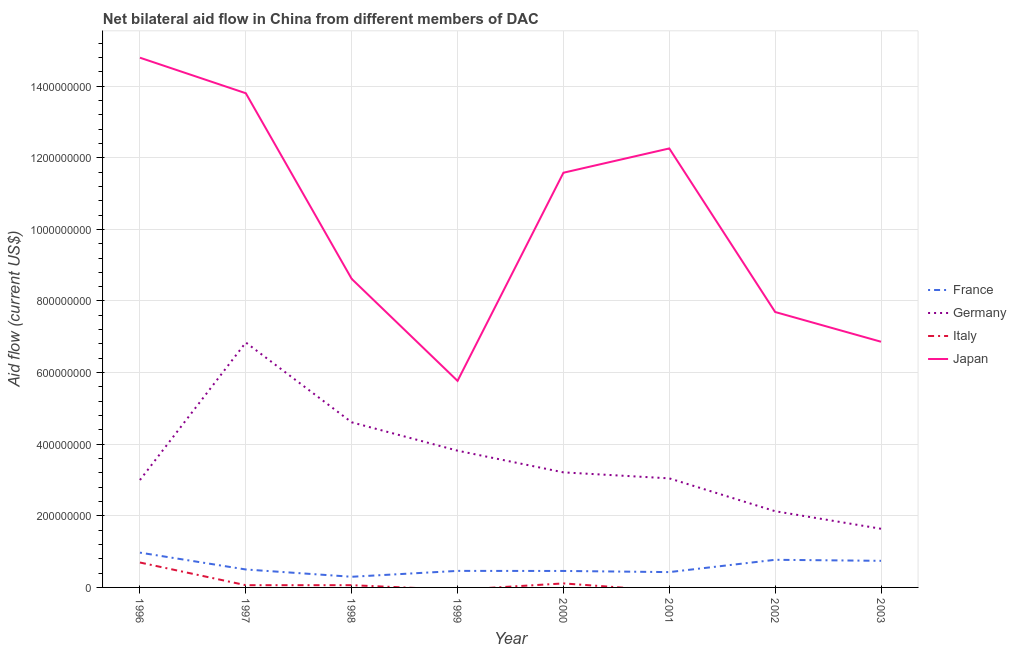How many different coloured lines are there?
Ensure brevity in your answer.  4. What is the amount of aid given by italy in 1998?
Your answer should be very brief. 6.24e+06. Across all years, what is the maximum amount of aid given by japan?
Offer a very short reply. 1.48e+09. Across all years, what is the minimum amount of aid given by germany?
Your answer should be compact. 1.64e+08. In which year was the amount of aid given by italy maximum?
Make the answer very short. 1996. What is the total amount of aid given by france in the graph?
Your answer should be compact. 4.64e+08. What is the difference between the amount of aid given by germany in 2001 and that in 2002?
Provide a succinct answer. 9.18e+07. What is the difference between the amount of aid given by germany in 1997 and the amount of aid given by japan in 2003?
Offer a very short reply. -2.08e+06. What is the average amount of aid given by japan per year?
Provide a short and direct response. 1.02e+09. In the year 2000, what is the difference between the amount of aid given by germany and amount of aid given by france?
Give a very brief answer. 2.75e+08. What is the ratio of the amount of aid given by germany in 1996 to that in 1997?
Your response must be concise. 0.44. Is the amount of aid given by japan in 1999 less than that in 2003?
Make the answer very short. Yes. Is the difference between the amount of aid given by germany in 1999 and 2000 greater than the difference between the amount of aid given by japan in 1999 and 2000?
Offer a very short reply. Yes. What is the difference between the highest and the second highest amount of aid given by japan?
Provide a succinct answer. 9.93e+07. What is the difference between the highest and the lowest amount of aid given by japan?
Your response must be concise. 9.03e+08. In how many years, is the amount of aid given by france greater than the average amount of aid given by france taken over all years?
Give a very brief answer. 3. Is it the case that in every year, the sum of the amount of aid given by japan and amount of aid given by germany is greater than the sum of amount of aid given by france and amount of aid given by italy?
Your answer should be compact. No. Is the amount of aid given by italy strictly less than the amount of aid given by germany over the years?
Your answer should be very brief. Yes. How many lines are there?
Your response must be concise. 4. How many years are there in the graph?
Provide a succinct answer. 8. What is the difference between two consecutive major ticks on the Y-axis?
Your answer should be very brief. 2.00e+08. Are the values on the major ticks of Y-axis written in scientific E-notation?
Offer a terse response. No. Does the graph contain grids?
Provide a succinct answer. Yes. Where does the legend appear in the graph?
Your answer should be compact. Center right. How many legend labels are there?
Provide a short and direct response. 4. How are the legend labels stacked?
Keep it short and to the point. Vertical. What is the title of the graph?
Your answer should be compact. Net bilateral aid flow in China from different members of DAC. Does "Methodology assessment" appear as one of the legend labels in the graph?
Provide a succinct answer. No. What is the label or title of the Y-axis?
Provide a succinct answer. Aid flow (current US$). What is the Aid flow (current US$) of France in 1996?
Your answer should be very brief. 9.72e+07. What is the Aid flow (current US$) of Germany in 1996?
Offer a terse response. 3.00e+08. What is the Aid flow (current US$) of Italy in 1996?
Offer a terse response. 6.96e+07. What is the Aid flow (current US$) of Japan in 1996?
Make the answer very short. 1.48e+09. What is the Aid flow (current US$) of France in 1997?
Provide a short and direct response. 5.01e+07. What is the Aid flow (current US$) of Germany in 1997?
Keep it short and to the point. 6.84e+08. What is the Aid flow (current US$) in Italy in 1997?
Your answer should be compact. 6.23e+06. What is the Aid flow (current US$) of Japan in 1997?
Make the answer very short. 1.38e+09. What is the Aid flow (current US$) of France in 1998?
Offer a terse response. 2.98e+07. What is the Aid flow (current US$) of Germany in 1998?
Keep it short and to the point. 4.61e+08. What is the Aid flow (current US$) of Italy in 1998?
Offer a terse response. 6.24e+06. What is the Aid flow (current US$) in Japan in 1998?
Give a very brief answer. 8.62e+08. What is the Aid flow (current US$) in France in 1999?
Ensure brevity in your answer.  4.62e+07. What is the Aid flow (current US$) in Germany in 1999?
Your response must be concise. 3.82e+08. What is the Aid flow (current US$) in Italy in 1999?
Make the answer very short. 0. What is the Aid flow (current US$) of Japan in 1999?
Give a very brief answer. 5.77e+08. What is the Aid flow (current US$) of France in 2000?
Your answer should be compact. 4.60e+07. What is the Aid flow (current US$) in Germany in 2000?
Your answer should be very brief. 3.21e+08. What is the Aid flow (current US$) of Italy in 2000?
Offer a very short reply. 1.12e+07. What is the Aid flow (current US$) in Japan in 2000?
Your answer should be very brief. 1.16e+09. What is the Aid flow (current US$) in France in 2001?
Offer a very short reply. 4.28e+07. What is the Aid flow (current US$) of Germany in 2001?
Your answer should be very brief. 3.05e+08. What is the Aid flow (current US$) in Italy in 2001?
Provide a succinct answer. 0. What is the Aid flow (current US$) in Japan in 2001?
Ensure brevity in your answer.  1.23e+09. What is the Aid flow (current US$) of France in 2002?
Make the answer very short. 7.72e+07. What is the Aid flow (current US$) in Germany in 2002?
Provide a succinct answer. 2.13e+08. What is the Aid flow (current US$) of Japan in 2002?
Offer a terse response. 7.69e+08. What is the Aid flow (current US$) in France in 2003?
Your response must be concise. 7.43e+07. What is the Aid flow (current US$) in Germany in 2003?
Provide a short and direct response. 1.64e+08. What is the Aid flow (current US$) in Italy in 2003?
Make the answer very short. 0. What is the Aid flow (current US$) in Japan in 2003?
Ensure brevity in your answer.  6.86e+08. Across all years, what is the maximum Aid flow (current US$) in France?
Your response must be concise. 9.72e+07. Across all years, what is the maximum Aid flow (current US$) in Germany?
Provide a succinct answer. 6.84e+08. Across all years, what is the maximum Aid flow (current US$) in Italy?
Make the answer very short. 6.96e+07. Across all years, what is the maximum Aid flow (current US$) of Japan?
Give a very brief answer. 1.48e+09. Across all years, what is the minimum Aid flow (current US$) in France?
Make the answer very short. 2.98e+07. Across all years, what is the minimum Aid flow (current US$) of Germany?
Offer a terse response. 1.64e+08. Across all years, what is the minimum Aid flow (current US$) in Japan?
Make the answer very short. 5.77e+08. What is the total Aid flow (current US$) of France in the graph?
Keep it short and to the point. 4.64e+08. What is the total Aid flow (current US$) of Germany in the graph?
Provide a succinct answer. 2.83e+09. What is the total Aid flow (current US$) of Italy in the graph?
Provide a succinct answer. 9.33e+07. What is the total Aid flow (current US$) in Japan in the graph?
Provide a short and direct response. 8.14e+09. What is the difference between the Aid flow (current US$) of France in 1996 and that in 1997?
Your response must be concise. 4.71e+07. What is the difference between the Aid flow (current US$) in Germany in 1996 and that in 1997?
Offer a very short reply. -3.84e+08. What is the difference between the Aid flow (current US$) in Italy in 1996 and that in 1997?
Your answer should be compact. 6.34e+07. What is the difference between the Aid flow (current US$) of Japan in 1996 and that in 1997?
Offer a very short reply. 9.93e+07. What is the difference between the Aid flow (current US$) of France in 1996 and that in 1998?
Offer a very short reply. 6.74e+07. What is the difference between the Aid flow (current US$) in Germany in 1996 and that in 1998?
Your answer should be very brief. -1.61e+08. What is the difference between the Aid flow (current US$) in Italy in 1996 and that in 1998?
Offer a very short reply. 6.34e+07. What is the difference between the Aid flow (current US$) of Japan in 1996 and that in 1998?
Give a very brief answer. 6.18e+08. What is the difference between the Aid flow (current US$) of France in 1996 and that in 1999?
Your response must be concise. 5.10e+07. What is the difference between the Aid flow (current US$) in Germany in 1996 and that in 1999?
Offer a very short reply. -8.19e+07. What is the difference between the Aid flow (current US$) of Japan in 1996 and that in 1999?
Your answer should be very brief. 9.03e+08. What is the difference between the Aid flow (current US$) in France in 1996 and that in 2000?
Your answer should be compact. 5.12e+07. What is the difference between the Aid flow (current US$) of Germany in 1996 and that in 2000?
Keep it short and to the point. -2.13e+07. What is the difference between the Aid flow (current US$) of Italy in 1996 and that in 2000?
Offer a very short reply. 5.84e+07. What is the difference between the Aid flow (current US$) of Japan in 1996 and that in 2000?
Ensure brevity in your answer.  3.21e+08. What is the difference between the Aid flow (current US$) of France in 1996 and that in 2001?
Make the answer very short. 5.44e+07. What is the difference between the Aid flow (current US$) of Germany in 1996 and that in 2001?
Offer a very short reply. -4.60e+06. What is the difference between the Aid flow (current US$) in Japan in 1996 and that in 2001?
Your answer should be very brief. 2.53e+08. What is the difference between the Aid flow (current US$) in Germany in 1996 and that in 2002?
Provide a short and direct response. 8.72e+07. What is the difference between the Aid flow (current US$) in Japan in 1996 and that in 2002?
Your response must be concise. 7.10e+08. What is the difference between the Aid flow (current US$) in France in 1996 and that in 2003?
Give a very brief answer. 2.29e+07. What is the difference between the Aid flow (current US$) of Germany in 1996 and that in 2003?
Keep it short and to the point. 1.36e+08. What is the difference between the Aid flow (current US$) in Japan in 1996 and that in 2003?
Your answer should be compact. 7.93e+08. What is the difference between the Aid flow (current US$) of France in 1997 and that in 1998?
Give a very brief answer. 2.04e+07. What is the difference between the Aid flow (current US$) in Germany in 1997 and that in 1998?
Offer a terse response. 2.23e+08. What is the difference between the Aid flow (current US$) of Japan in 1997 and that in 1998?
Give a very brief answer. 5.18e+08. What is the difference between the Aid flow (current US$) in France in 1997 and that in 1999?
Provide a succinct answer. 3.94e+06. What is the difference between the Aid flow (current US$) in Germany in 1997 and that in 1999?
Offer a very short reply. 3.02e+08. What is the difference between the Aid flow (current US$) in Japan in 1997 and that in 1999?
Give a very brief answer. 8.03e+08. What is the difference between the Aid flow (current US$) in France in 1997 and that in 2000?
Keep it short and to the point. 4.12e+06. What is the difference between the Aid flow (current US$) in Germany in 1997 and that in 2000?
Make the answer very short. 3.63e+08. What is the difference between the Aid flow (current US$) in Italy in 1997 and that in 2000?
Your answer should be very brief. -4.97e+06. What is the difference between the Aid flow (current US$) in Japan in 1997 and that in 2000?
Give a very brief answer. 2.22e+08. What is the difference between the Aid flow (current US$) in France in 1997 and that in 2001?
Provide a succinct answer. 7.31e+06. What is the difference between the Aid flow (current US$) of Germany in 1997 and that in 2001?
Make the answer very short. 3.79e+08. What is the difference between the Aid flow (current US$) in Japan in 1997 and that in 2001?
Offer a very short reply. 1.54e+08. What is the difference between the Aid flow (current US$) in France in 1997 and that in 2002?
Your response must be concise. -2.71e+07. What is the difference between the Aid flow (current US$) of Germany in 1997 and that in 2002?
Give a very brief answer. 4.71e+08. What is the difference between the Aid flow (current US$) of Japan in 1997 and that in 2002?
Keep it short and to the point. 6.11e+08. What is the difference between the Aid flow (current US$) in France in 1997 and that in 2003?
Your response must be concise. -2.42e+07. What is the difference between the Aid flow (current US$) in Germany in 1997 and that in 2003?
Provide a succinct answer. 5.20e+08. What is the difference between the Aid flow (current US$) of Japan in 1997 and that in 2003?
Your answer should be compact. 6.94e+08. What is the difference between the Aid flow (current US$) of France in 1998 and that in 1999?
Offer a very short reply. -1.64e+07. What is the difference between the Aid flow (current US$) in Germany in 1998 and that in 1999?
Give a very brief answer. 7.92e+07. What is the difference between the Aid flow (current US$) in Japan in 1998 and that in 1999?
Keep it short and to the point. 2.85e+08. What is the difference between the Aid flow (current US$) of France in 1998 and that in 2000?
Make the answer very short. -1.62e+07. What is the difference between the Aid flow (current US$) in Germany in 1998 and that in 2000?
Give a very brief answer. 1.40e+08. What is the difference between the Aid flow (current US$) of Italy in 1998 and that in 2000?
Keep it short and to the point. -4.96e+06. What is the difference between the Aid flow (current US$) in Japan in 1998 and that in 2000?
Provide a succinct answer. -2.96e+08. What is the difference between the Aid flow (current US$) of France in 1998 and that in 2001?
Your answer should be compact. -1.30e+07. What is the difference between the Aid flow (current US$) in Germany in 1998 and that in 2001?
Provide a short and direct response. 1.57e+08. What is the difference between the Aid flow (current US$) in Japan in 1998 and that in 2001?
Give a very brief answer. -3.64e+08. What is the difference between the Aid flow (current US$) of France in 1998 and that in 2002?
Your response must be concise. -4.74e+07. What is the difference between the Aid flow (current US$) in Germany in 1998 and that in 2002?
Give a very brief answer. 2.48e+08. What is the difference between the Aid flow (current US$) of Japan in 1998 and that in 2002?
Give a very brief answer. 9.25e+07. What is the difference between the Aid flow (current US$) of France in 1998 and that in 2003?
Provide a succinct answer. -4.45e+07. What is the difference between the Aid flow (current US$) in Germany in 1998 and that in 2003?
Ensure brevity in your answer.  2.97e+08. What is the difference between the Aid flow (current US$) of Japan in 1998 and that in 2003?
Offer a very short reply. 1.76e+08. What is the difference between the Aid flow (current US$) in France in 1999 and that in 2000?
Offer a terse response. 1.80e+05. What is the difference between the Aid flow (current US$) in Germany in 1999 and that in 2000?
Ensure brevity in your answer.  6.06e+07. What is the difference between the Aid flow (current US$) in Japan in 1999 and that in 2000?
Keep it short and to the point. -5.81e+08. What is the difference between the Aid flow (current US$) of France in 1999 and that in 2001?
Your answer should be very brief. 3.37e+06. What is the difference between the Aid flow (current US$) in Germany in 1999 and that in 2001?
Your response must be concise. 7.73e+07. What is the difference between the Aid flow (current US$) of Japan in 1999 and that in 2001?
Make the answer very short. -6.49e+08. What is the difference between the Aid flow (current US$) in France in 1999 and that in 2002?
Your answer should be very brief. -3.10e+07. What is the difference between the Aid flow (current US$) of Germany in 1999 and that in 2002?
Give a very brief answer. 1.69e+08. What is the difference between the Aid flow (current US$) of Japan in 1999 and that in 2002?
Keep it short and to the point. -1.92e+08. What is the difference between the Aid flow (current US$) of France in 1999 and that in 2003?
Provide a succinct answer. -2.81e+07. What is the difference between the Aid flow (current US$) in Germany in 1999 and that in 2003?
Offer a terse response. 2.18e+08. What is the difference between the Aid flow (current US$) in Japan in 1999 and that in 2003?
Ensure brevity in your answer.  -1.09e+08. What is the difference between the Aid flow (current US$) in France in 2000 and that in 2001?
Ensure brevity in your answer.  3.19e+06. What is the difference between the Aid flow (current US$) in Germany in 2000 and that in 2001?
Your answer should be very brief. 1.67e+07. What is the difference between the Aid flow (current US$) of Japan in 2000 and that in 2001?
Provide a succinct answer. -6.78e+07. What is the difference between the Aid flow (current US$) of France in 2000 and that in 2002?
Provide a short and direct response. -3.12e+07. What is the difference between the Aid flow (current US$) in Germany in 2000 and that in 2002?
Give a very brief answer. 1.08e+08. What is the difference between the Aid flow (current US$) of Japan in 2000 and that in 2002?
Ensure brevity in your answer.  3.89e+08. What is the difference between the Aid flow (current US$) of France in 2000 and that in 2003?
Make the answer very short. -2.83e+07. What is the difference between the Aid flow (current US$) of Germany in 2000 and that in 2003?
Your response must be concise. 1.57e+08. What is the difference between the Aid flow (current US$) in Japan in 2000 and that in 2003?
Provide a succinct answer. 4.72e+08. What is the difference between the Aid flow (current US$) in France in 2001 and that in 2002?
Your answer should be very brief. -3.44e+07. What is the difference between the Aid flow (current US$) of Germany in 2001 and that in 2002?
Your answer should be very brief. 9.18e+07. What is the difference between the Aid flow (current US$) of Japan in 2001 and that in 2002?
Your response must be concise. 4.57e+08. What is the difference between the Aid flow (current US$) in France in 2001 and that in 2003?
Make the answer very short. -3.15e+07. What is the difference between the Aid flow (current US$) of Germany in 2001 and that in 2003?
Offer a very short reply. 1.41e+08. What is the difference between the Aid flow (current US$) in Japan in 2001 and that in 2003?
Provide a succinct answer. 5.40e+08. What is the difference between the Aid flow (current US$) in France in 2002 and that in 2003?
Your response must be concise. 2.90e+06. What is the difference between the Aid flow (current US$) in Germany in 2002 and that in 2003?
Keep it short and to the point. 4.90e+07. What is the difference between the Aid flow (current US$) in Japan in 2002 and that in 2003?
Your answer should be very brief. 8.31e+07. What is the difference between the Aid flow (current US$) in France in 1996 and the Aid flow (current US$) in Germany in 1997?
Provide a succinct answer. -5.87e+08. What is the difference between the Aid flow (current US$) in France in 1996 and the Aid flow (current US$) in Italy in 1997?
Make the answer very short. 9.10e+07. What is the difference between the Aid flow (current US$) of France in 1996 and the Aid flow (current US$) of Japan in 1997?
Your answer should be compact. -1.28e+09. What is the difference between the Aid flow (current US$) of Germany in 1996 and the Aid flow (current US$) of Italy in 1997?
Provide a succinct answer. 2.94e+08. What is the difference between the Aid flow (current US$) of Germany in 1996 and the Aid flow (current US$) of Japan in 1997?
Offer a terse response. -1.08e+09. What is the difference between the Aid flow (current US$) in Italy in 1996 and the Aid flow (current US$) in Japan in 1997?
Offer a very short reply. -1.31e+09. What is the difference between the Aid flow (current US$) of France in 1996 and the Aid flow (current US$) of Germany in 1998?
Give a very brief answer. -3.64e+08. What is the difference between the Aid flow (current US$) in France in 1996 and the Aid flow (current US$) in Italy in 1998?
Offer a very short reply. 9.10e+07. What is the difference between the Aid flow (current US$) in France in 1996 and the Aid flow (current US$) in Japan in 1998?
Your response must be concise. -7.65e+08. What is the difference between the Aid flow (current US$) of Germany in 1996 and the Aid flow (current US$) of Italy in 1998?
Your response must be concise. 2.94e+08. What is the difference between the Aid flow (current US$) of Germany in 1996 and the Aid flow (current US$) of Japan in 1998?
Your response must be concise. -5.62e+08. What is the difference between the Aid flow (current US$) in Italy in 1996 and the Aid flow (current US$) in Japan in 1998?
Your answer should be compact. -7.92e+08. What is the difference between the Aid flow (current US$) of France in 1996 and the Aid flow (current US$) of Germany in 1999?
Give a very brief answer. -2.85e+08. What is the difference between the Aid flow (current US$) in France in 1996 and the Aid flow (current US$) in Japan in 1999?
Ensure brevity in your answer.  -4.80e+08. What is the difference between the Aid flow (current US$) in Germany in 1996 and the Aid flow (current US$) in Japan in 1999?
Your answer should be compact. -2.77e+08. What is the difference between the Aid flow (current US$) in Italy in 1996 and the Aid flow (current US$) in Japan in 1999?
Your response must be concise. -5.07e+08. What is the difference between the Aid flow (current US$) of France in 1996 and the Aid flow (current US$) of Germany in 2000?
Offer a very short reply. -2.24e+08. What is the difference between the Aid flow (current US$) of France in 1996 and the Aid flow (current US$) of Italy in 2000?
Give a very brief answer. 8.60e+07. What is the difference between the Aid flow (current US$) of France in 1996 and the Aid flow (current US$) of Japan in 2000?
Provide a succinct answer. -1.06e+09. What is the difference between the Aid flow (current US$) in Germany in 1996 and the Aid flow (current US$) in Italy in 2000?
Make the answer very short. 2.89e+08. What is the difference between the Aid flow (current US$) of Germany in 1996 and the Aid flow (current US$) of Japan in 2000?
Provide a succinct answer. -8.58e+08. What is the difference between the Aid flow (current US$) of Italy in 1996 and the Aid flow (current US$) of Japan in 2000?
Give a very brief answer. -1.09e+09. What is the difference between the Aid flow (current US$) of France in 1996 and the Aid flow (current US$) of Germany in 2001?
Keep it short and to the point. -2.07e+08. What is the difference between the Aid flow (current US$) in France in 1996 and the Aid flow (current US$) in Japan in 2001?
Offer a terse response. -1.13e+09. What is the difference between the Aid flow (current US$) in Germany in 1996 and the Aid flow (current US$) in Japan in 2001?
Offer a terse response. -9.26e+08. What is the difference between the Aid flow (current US$) in Italy in 1996 and the Aid flow (current US$) in Japan in 2001?
Ensure brevity in your answer.  -1.16e+09. What is the difference between the Aid flow (current US$) of France in 1996 and the Aid flow (current US$) of Germany in 2002?
Give a very brief answer. -1.16e+08. What is the difference between the Aid flow (current US$) of France in 1996 and the Aid flow (current US$) of Japan in 2002?
Provide a succinct answer. -6.72e+08. What is the difference between the Aid flow (current US$) of Germany in 1996 and the Aid flow (current US$) of Japan in 2002?
Provide a succinct answer. -4.69e+08. What is the difference between the Aid flow (current US$) in Italy in 1996 and the Aid flow (current US$) in Japan in 2002?
Your response must be concise. -7.00e+08. What is the difference between the Aid flow (current US$) of France in 1996 and the Aid flow (current US$) of Germany in 2003?
Ensure brevity in your answer.  -6.66e+07. What is the difference between the Aid flow (current US$) in France in 1996 and the Aid flow (current US$) in Japan in 2003?
Your response must be concise. -5.89e+08. What is the difference between the Aid flow (current US$) in Germany in 1996 and the Aid flow (current US$) in Japan in 2003?
Keep it short and to the point. -3.86e+08. What is the difference between the Aid flow (current US$) in Italy in 1996 and the Aid flow (current US$) in Japan in 2003?
Ensure brevity in your answer.  -6.17e+08. What is the difference between the Aid flow (current US$) in France in 1997 and the Aid flow (current US$) in Germany in 1998?
Ensure brevity in your answer.  -4.11e+08. What is the difference between the Aid flow (current US$) of France in 1997 and the Aid flow (current US$) of Italy in 1998?
Your answer should be compact. 4.39e+07. What is the difference between the Aid flow (current US$) in France in 1997 and the Aid flow (current US$) in Japan in 1998?
Your response must be concise. -8.12e+08. What is the difference between the Aid flow (current US$) in Germany in 1997 and the Aid flow (current US$) in Italy in 1998?
Offer a very short reply. 6.78e+08. What is the difference between the Aid flow (current US$) in Germany in 1997 and the Aid flow (current US$) in Japan in 1998?
Your response must be concise. -1.78e+08. What is the difference between the Aid flow (current US$) in Italy in 1997 and the Aid flow (current US$) in Japan in 1998?
Offer a very short reply. -8.55e+08. What is the difference between the Aid flow (current US$) in France in 1997 and the Aid flow (current US$) in Germany in 1999?
Your answer should be compact. -3.32e+08. What is the difference between the Aid flow (current US$) of France in 1997 and the Aid flow (current US$) of Japan in 1999?
Your response must be concise. -5.27e+08. What is the difference between the Aid flow (current US$) in Germany in 1997 and the Aid flow (current US$) in Japan in 1999?
Provide a short and direct response. 1.07e+08. What is the difference between the Aid flow (current US$) of Italy in 1997 and the Aid flow (current US$) of Japan in 1999?
Make the answer very short. -5.71e+08. What is the difference between the Aid flow (current US$) of France in 1997 and the Aid flow (current US$) of Germany in 2000?
Keep it short and to the point. -2.71e+08. What is the difference between the Aid flow (current US$) in France in 1997 and the Aid flow (current US$) in Italy in 2000?
Your answer should be very brief. 3.89e+07. What is the difference between the Aid flow (current US$) of France in 1997 and the Aid flow (current US$) of Japan in 2000?
Your response must be concise. -1.11e+09. What is the difference between the Aid flow (current US$) in Germany in 1997 and the Aid flow (current US$) in Italy in 2000?
Offer a very short reply. 6.73e+08. What is the difference between the Aid flow (current US$) of Germany in 1997 and the Aid flow (current US$) of Japan in 2000?
Provide a succinct answer. -4.74e+08. What is the difference between the Aid flow (current US$) of Italy in 1997 and the Aid flow (current US$) of Japan in 2000?
Ensure brevity in your answer.  -1.15e+09. What is the difference between the Aid flow (current US$) in France in 1997 and the Aid flow (current US$) in Germany in 2001?
Provide a succinct answer. -2.54e+08. What is the difference between the Aid flow (current US$) of France in 1997 and the Aid flow (current US$) of Japan in 2001?
Provide a short and direct response. -1.18e+09. What is the difference between the Aid flow (current US$) of Germany in 1997 and the Aid flow (current US$) of Japan in 2001?
Keep it short and to the point. -5.42e+08. What is the difference between the Aid flow (current US$) of Italy in 1997 and the Aid flow (current US$) of Japan in 2001?
Give a very brief answer. -1.22e+09. What is the difference between the Aid flow (current US$) in France in 1997 and the Aid flow (current US$) in Germany in 2002?
Your answer should be very brief. -1.63e+08. What is the difference between the Aid flow (current US$) in France in 1997 and the Aid flow (current US$) in Japan in 2002?
Offer a terse response. -7.19e+08. What is the difference between the Aid flow (current US$) of Germany in 1997 and the Aid flow (current US$) of Japan in 2002?
Keep it short and to the point. -8.51e+07. What is the difference between the Aid flow (current US$) in Italy in 1997 and the Aid flow (current US$) in Japan in 2002?
Offer a terse response. -7.63e+08. What is the difference between the Aid flow (current US$) of France in 1997 and the Aid flow (current US$) of Germany in 2003?
Offer a terse response. -1.14e+08. What is the difference between the Aid flow (current US$) of France in 1997 and the Aid flow (current US$) of Japan in 2003?
Your answer should be compact. -6.36e+08. What is the difference between the Aid flow (current US$) of Germany in 1997 and the Aid flow (current US$) of Japan in 2003?
Your answer should be compact. -2.08e+06. What is the difference between the Aid flow (current US$) in Italy in 1997 and the Aid flow (current US$) in Japan in 2003?
Your answer should be very brief. -6.80e+08. What is the difference between the Aid flow (current US$) of France in 1998 and the Aid flow (current US$) of Germany in 1999?
Offer a terse response. -3.52e+08. What is the difference between the Aid flow (current US$) in France in 1998 and the Aid flow (current US$) in Japan in 1999?
Offer a very short reply. -5.47e+08. What is the difference between the Aid flow (current US$) in Germany in 1998 and the Aid flow (current US$) in Japan in 1999?
Offer a very short reply. -1.16e+08. What is the difference between the Aid flow (current US$) in Italy in 1998 and the Aid flow (current US$) in Japan in 1999?
Your response must be concise. -5.71e+08. What is the difference between the Aid flow (current US$) of France in 1998 and the Aid flow (current US$) of Germany in 2000?
Provide a succinct answer. -2.92e+08. What is the difference between the Aid flow (current US$) of France in 1998 and the Aid flow (current US$) of Italy in 2000?
Provide a short and direct response. 1.86e+07. What is the difference between the Aid flow (current US$) in France in 1998 and the Aid flow (current US$) in Japan in 2000?
Keep it short and to the point. -1.13e+09. What is the difference between the Aid flow (current US$) of Germany in 1998 and the Aid flow (current US$) of Italy in 2000?
Make the answer very short. 4.50e+08. What is the difference between the Aid flow (current US$) of Germany in 1998 and the Aid flow (current US$) of Japan in 2000?
Provide a short and direct response. -6.97e+08. What is the difference between the Aid flow (current US$) of Italy in 1998 and the Aid flow (current US$) of Japan in 2000?
Your answer should be very brief. -1.15e+09. What is the difference between the Aid flow (current US$) of France in 1998 and the Aid flow (current US$) of Germany in 2001?
Your answer should be very brief. -2.75e+08. What is the difference between the Aid flow (current US$) of France in 1998 and the Aid flow (current US$) of Japan in 2001?
Offer a terse response. -1.20e+09. What is the difference between the Aid flow (current US$) of Germany in 1998 and the Aid flow (current US$) of Japan in 2001?
Make the answer very short. -7.65e+08. What is the difference between the Aid flow (current US$) in Italy in 1998 and the Aid flow (current US$) in Japan in 2001?
Make the answer very short. -1.22e+09. What is the difference between the Aid flow (current US$) in France in 1998 and the Aid flow (current US$) in Germany in 2002?
Your answer should be very brief. -1.83e+08. What is the difference between the Aid flow (current US$) of France in 1998 and the Aid flow (current US$) of Japan in 2002?
Keep it short and to the point. -7.39e+08. What is the difference between the Aid flow (current US$) of Germany in 1998 and the Aid flow (current US$) of Japan in 2002?
Offer a terse response. -3.08e+08. What is the difference between the Aid flow (current US$) of Italy in 1998 and the Aid flow (current US$) of Japan in 2002?
Keep it short and to the point. -7.63e+08. What is the difference between the Aid flow (current US$) in France in 1998 and the Aid flow (current US$) in Germany in 2003?
Your response must be concise. -1.34e+08. What is the difference between the Aid flow (current US$) in France in 1998 and the Aid flow (current US$) in Japan in 2003?
Your answer should be very brief. -6.56e+08. What is the difference between the Aid flow (current US$) in Germany in 1998 and the Aid flow (current US$) in Japan in 2003?
Your answer should be compact. -2.25e+08. What is the difference between the Aid flow (current US$) of Italy in 1998 and the Aid flow (current US$) of Japan in 2003?
Give a very brief answer. -6.80e+08. What is the difference between the Aid flow (current US$) of France in 1999 and the Aid flow (current US$) of Germany in 2000?
Your response must be concise. -2.75e+08. What is the difference between the Aid flow (current US$) in France in 1999 and the Aid flow (current US$) in Italy in 2000?
Ensure brevity in your answer.  3.50e+07. What is the difference between the Aid flow (current US$) of France in 1999 and the Aid flow (current US$) of Japan in 2000?
Offer a terse response. -1.11e+09. What is the difference between the Aid flow (current US$) of Germany in 1999 and the Aid flow (current US$) of Italy in 2000?
Ensure brevity in your answer.  3.71e+08. What is the difference between the Aid flow (current US$) of Germany in 1999 and the Aid flow (current US$) of Japan in 2000?
Your response must be concise. -7.76e+08. What is the difference between the Aid flow (current US$) in France in 1999 and the Aid flow (current US$) in Germany in 2001?
Offer a very short reply. -2.58e+08. What is the difference between the Aid flow (current US$) in France in 1999 and the Aid flow (current US$) in Japan in 2001?
Offer a very short reply. -1.18e+09. What is the difference between the Aid flow (current US$) in Germany in 1999 and the Aid flow (current US$) in Japan in 2001?
Give a very brief answer. -8.44e+08. What is the difference between the Aid flow (current US$) of France in 1999 and the Aid flow (current US$) of Germany in 2002?
Your answer should be very brief. -1.67e+08. What is the difference between the Aid flow (current US$) of France in 1999 and the Aid flow (current US$) of Japan in 2002?
Your answer should be very brief. -7.23e+08. What is the difference between the Aid flow (current US$) of Germany in 1999 and the Aid flow (current US$) of Japan in 2002?
Ensure brevity in your answer.  -3.87e+08. What is the difference between the Aid flow (current US$) in France in 1999 and the Aid flow (current US$) in Germany in 2003?
Make the answer very short. -1.18e+08. What is the difference between the Aid flow (current US$) of France in 1999 and the Aid flow (current US$) of Japan in 2003?
Provide a short and direct response. -6.40e+08. What is the difference between the Aid flow (current US$) of Germany in 1999 and the Aid flow (current US$) of Japan in 2003?
Your answer should be compact. -3.04e+08. What is the difference between the Aid flow (current US$) in France in 2000 and the Aid flow (current US$) in Germany in 2001?
Provide a succinct answer. -2.59e+08. What is the difference between the Aid flow (current US$) in France in 2000 and the Aid flow (current US$) in Japan in 2001?
Provide a short and direct response. -1.18e+09. What is the difference between the Aid flow (current US$) of Germany in 2000 and the Aid flow (current US$) of Japan in 2001?
Ensure brevity in your answer.  -9.05e+08. What is the difference between the Aid flow (current US$) of Italy in 2000 and the Aid flow (current US$) of Japan in 2001?
Make the answer very short. -1.21e+09. What is the difference between the Aid flow (current US$) of France in 2000 and the Aid flow (current US$) of Germany in 2002?
Make the answer very short. -1.67e+08. What is the difference between the Aid flow (current US$) in France in 2000 and the Aid flow (current US$) in Japan in 2002?
Give a very brief answer. -7.23e+08. What is the difference between the Aid flow (current US$) in Germany in 2000 and the Aid flow (current US$) in Japan in 2002?
Your response must be concise. -4.48e+08. What is the difference between the Aid flow (current US$) in Italy in 2000 and the Aid flow (current US$) in Japan in 2002?
Offer a very short reply. -7.58e+08. What is the difference between the Aid flow (current US$) in France in 2000 and the Aid flow (current US$) in Germany in 2003?
Give a very brief answer. -1.18e+08. What is the difference between the Aid flow (current US$) in France in 2000 and the Aid flow (current US$) in Japan in 2003?
Your answer should be very brief. -6.40e+08. What is the difference between the Aid flow (current US$) of Germany in 2000 and the Aid flow (current US$) of Japan in 2003?
Your answer should be very brief. -3.65e+08. What is the difference between the Aid flow (current US$) in Italy in 2000 and the Aid flow (current US$) in Japan in 2003?
Offer a terse response. -6.75e+08. What is the difference between the Aid flow (current US$) of France in 2001 and the Aid flow (current US$) of Germany in 2002?
Offer a very short reply. -1.70e+08. What is the difference between the Aid flow (current US$) of France in 2001 and the Aid flow (current US$) of Japan in 2002?
Keep it short and to the point. -7.26e+08. What is the difference between the Aid flow (current US$) in Germany in 2001 and the Aid flow (current US$) in Japan in 2002?
Your answer should be very brief. -4.65e+08. What is the difference between the Aid flow (current US$) of France in 2001 and the Aid flow (current US$) of Germany in 2003?
Offer a terse response. -1.21e+08. What is the difference between the Aid flow (current US$) of France in 2001 and the Aid flow (current US$) of Japan in 2003?
Your answer should be compact. -6.43e+08. What is the difference between the Aid flow (current US$) of Germany in 2001 and the Aid flow (current US$) of Japan in 2003?
Keep it short and to the point. -3.82e+08. What is the difference between the Aid flow (current US$) in France in 2002 and the Aid flow (current US$) in Germany in 2003?
Ensure brevity in your answer.  -8.66e+07. What is the difference between the Aid flow (current US$) in France in 2002 and the Aid flow (current US$) in Japan in 2003?
Your answer should be compact. -6.09e+08. What is the difference between the Aid flow (current US$) of Germany in 2002 and the Aid flow (current US$) of Japan in 2003?
Offer a terse response. -4.73e+08. What is the average Aid flow (current US$) in France per year?
Provide a succinct answer. 5.79e+07. What is the average Aid flow (current US$) of Germany per year?
Offer a very short reply. 3.54e+08. What is the average Aid flow (current US$) in Italy per year?
Your answer should be very brief. 1.17e+07. What is the average Aid flow (current US$) in Japan per year?
Your answer should be very brief. 1.02e+09. In the year 1996, what is the difference between the Aid flow (current US$) in France and Aid flow (current US$) in Germany?
Your answer should be compact. -2.03e+08. In the year 1996, what is the difference between the Aid flow (current US$) of France and Aid flow (current US$) of Italy?
Offer a very short reply. 2.76e+07. In the year 1996, what is the difference between the Aid flow (current US$) in France and Aid flow (current US$) in Japan?
Your answer should be compact. -1.38e+09. In the year 1996, what is the difference between the Aid flow (current US$) of Germany and Aid flow (current US$) of Italy?
Keep it short and to the point. 2.30e+08. In the year 1996, what is the difference between the Aid flow (current US$) in Germany and Aid flow (current US$) in Japan?
Your answer should be very brief. -1.18e+09. In the year 1996, what is the difference between the Aid flow (current US$) in Italy and Aid flow (current US$) in Japan?
Provide a succinct answer. -1.41e+09. In the year 1997, what is the difference between the Aid flow (current US$) of France and Aid flow (current US$) of Germany?
Make the answer very short. -6.34e+08. In the year 1997, what is the difference between the Aid flow (current US$) of France and Aid flow (current US$) of Italy?
Offer a terse response. 4.39e+07. In the year 1997, what is the difference between the Aid flow (current US$) of France and Aid flow (current US$) of Japan?
Keep it short and to the point. -1.33e+09. In the year 1997, what is the difference between the Aid flow (current US$) of Germany and Aid flow (current US$) of Italy?
Keep it short and to the point. 6.78e+08. In the year 1997, what is the difference between the Aid flow (current US$) of Germany and Aid flow (current US$) of Japan?
Your answer should be very brief. -6.96e+08. In the year 1997, what is the difference between the Aid flow (current US$) of Italy and Aid flow (current US$) of Japan?
Offer a very short reply. -1.37e+09. In the year 1998, what is the difference between the Aid flow (current US$) in France and Aid flow (current US$) in Germany?
Your response must be concise. -4.31e+08. In the year 1998, what is the difference between the Aid flow (current US$) in France and Aid flow (current US$) in Italy?
Provide a short and direct response. 2.35e+07. In the year 1998, what is the difference between the Aid flow (current US$) of France and Aid flow (current US$) of Japan?
Make the answer very short. -8.32e+08. In the year 1998, what is the difference between the Aid flow (current US$) of Germany and Aid flow (current US$) of Italy?
Your answer should be compact. 4.55e+08. In the year 1998, what is the difference between the Aid flow (current US$) in Germany and Aid flow (current US$) in Japan?
Offer a terse response. -4.01e+08. In the year 1998, what is the difference between the Aid flow (current US$) in Italy and Aid flow (current US$) in Japan?
Offer a terse response. -8.55e+08. In the year 1999, what is the difference between the Aid flow (current US$) of France and Aid flow (current US$) of Germany?
Give a very brief answer. -3.36e+08. In the year 1999, what is the difference between the Aid flow (current US$) in France and Aid flow (current US$) in Japan?
Give a very brief answer. -5.31e+08. In the year 1999, what is the difference between the Aid flow (current US$) in Germany and Aid flow (current US$) in Japan?
Offer a terse response. -1.95e+08. In the year 2000, what is the difference between the Aid flow (current US$) in France and Aid flow (current US$) in Germany?
Your answer should be compact. -2.75e+08. In the year 2000, what is the difference between the Aid flow (current US$) of France and Aid flow (current US$) of Italy?
Ensure brevity in your answer.  3.48e+07. In the year 2000, what is the difference between the Aid flow (current US$) of France and Aid flow (current US$) of Japan?
Your answer should be compact. -1.11e+09. In the year 2000, what is the difference between the Aid flow (current US$) in Germany and Aid flow (current US$) in Italy?
Provide a short and direct response. 3.10e+08. In the year 2000, what is the difference between the Aid flow (current US$) in Germany and Aid flow (current US$) in Japan?
Offer a very short reply. -8.37e+08. In the year 2000, what is the difference between the Aid flow (current US$) in Italy and Aid flow (current US$) in Japan?
Offer a very short reply. -1.15e+09. In the year 2001, what is the difference between the Aid flow (current US$) in France and Aid flow (current US$) in Germany?
Ensure brevity in your answer.  -2.62e+08. In the year 2001, what is the difference between the Aid flow (current US$) of France and Aid flow (current US$) of Japan?
Ensure brevity in your answer.  -1.18e+09. In the year 2001, what is the difference between the Aid flow (current US$) in Germany and Aid flow (current US$) in Japan?
Offer a terse response. -9.21e+08. In the year 2002, what is the difference between the Aid flow (current US$) in France and Aid flow (current US$) in Germany?
Offer a terse response. -1.36e+08. In the year 2002, what is the difference between the Aid flow (current US$) of France and Aid flow (current US$) of Japan?
Keep it short and to the point. -6.92e+08. In the year 2002, what is the difference between the Aid flow (current US$) in Germany and Aid flow (current US$) in Japan?
Provide a succinct answer. -5.56e+08. In the year 2003, what is the difference between the Aid flow (current US$) of France and Aid flow (current US$) of Germany?
Provide a succinct answer. -8.95e+07. In the year 2003, what is the difference between the Aid flow (current US$) in France and Aid flow (current US$) in Japan?
Keep it short and to the point. -6.12e+08. In the year 2003, what is the difference between the Aid flow (current US$) in Germany and Aid flow (current US$) in Japan?
Make the answer very short. -5.22e+08. What is the ratio of the Aid flow (current US$) in France in 1996 to that in 1997?
Your answer should be compact. 1.94. What is the ratio of the Aid flow (current US$) in Germany in 1996 to that in 1997?
Offer a terse response. 0.44. What is the ratio of the Aid flow (current US$) in Italy in 1996 to that in 1997?
Offer a very short reply. 11.17. What is the ratio of the Aid flow (current US$) of Japan in 1996 to that in 1997?
Your response must be concise. 1.07. What is the ratio of the Aid flow (current US$) in France in 1996 to that in 1998?
Provide a succinct answer. 3.27. What is the ratio of the Aid flow (current US$) in Germany in 1996 to that in 1998?
Your response must be concise. 0.65. What is the ratio of the Aid flow (current US$) in Italy in 1996 to that in 1998?
Ensure brevity in your answer.  11.15. What is the ratio of the Aid flow (current US$) of Japan in 1996 to that in 1998?
Provide a short and direct response. 1.72. What is the ratio of the Aid flow (current US$) in France in 1996 to that in 1999?
Your response must be concise. 2.1. What is the ratio of the Aid flow (current US$) of Germany in 1996 to that in 1999?
Provide a succinct answer. 0.79. What is the ratio of the Aid flow (current US$) of Japan in 1996 to that in 1999?
Your response must be concise. 2.56. What is the ratio of the Aid flow (current US$) in France in 1996 to that in 2000?
Offer a terse response. 2.11. What is the ratio of the Aid flow (current US$) of Germany in 1996 to that in 2000?
Give a very brief answer. 0.93. What is the ratio of the Aid flow (current US$) of Italy in 1996 to that in 2000?
Offer a very short reply. 6.21. What is the ratio of the Aid flow (current US$) in Japan in 1996 to that in 2000?
Keep it short and to the point. 1.28. What is the ratio of the Aid flow (current US$) in France in 1996 to that in 2001?
Provide a succinct answer. 2.27. What is the ratio of the Aid flow (current US$) in Germany in 1996 to that in 2001?
Provide a succinct answer. 0.98. What is the ratio of the Aid flow (current US$) in Japan in 1996 to that in 2001?
Offer a very short reply. 1.21. What is the ratio of the Aid flow (current US$) of France in 1996 to that in 2002?
Make the answer very short. 1.26. What is the ratio of the Aid flow (current US$) in Germany in 1996 to that in 2002?
Ensure brevity in your answer.  1.41. What is the ratio of the Aid flow (current US$) in Japan in 1996 to that in 2002?
Provide a succinct answer. 1.92. What is the ratio of the Aid flow (current US$) in France in 1996 to that in 2003?
Offer a very short reply. 1.31. What is the ratio of the Aid flow (current US$) in Germany in 1996 to that in 2003?
Offer a terse response. 1.83. What is the ratio of the Aid flow (current US$) in Japan in 1996 to that in 2003?
Provide a succinct answer. 2.16. What is the ratio of the Aid flow (current US$) of France in 1997 to that in 1998?
Make the answer very short. 1.68. What is the ratio of the Aid flow (current US$) of Germany in 1997 to that in 1998?
Make the answer very short. 1.48. What is the ratio of the Aid flow (current US$) in Italy in 1997 to that in 1998?
Offer a very short reply. 1. What is the ratio of the Aid flow (current US$) of Japan in 1997 to that in 1998?
Provide a succinct answer. 1.6. What is the ratio of the Aid flow (current US$) in France in 1997 to that in 1999?
Offer a very short reply. 1.09. What is the ratio of the Aid flow (current US$) of Germany in 1997 to that in 1999?
Keep it short and to the point. 1.79. What is the ratio of the Aid flow (current US$) in Japan in 1997 to that in 1999?
Give a very brief answer. 2.39. What is the ratio of the Aid flow (current US$) of France in 1997 to that in 2000?
Keep it short and to the point. 1.09. What is the ratio of the Aid flow (current US$) of Germany in 1997 to that in 2000?
Your response must be concise. 2.13. What is the ratio of the Aid flow (current US$) in Italy in 1997 to that in 2000?
Your response must be concise. 0.56. What is the ratio of the Aid flow (current US$) in Japan in 1997 to that in 2000?
Your response must be concise. 1.19. What is the ratio of the Aid flow (current US$) in France in 1997 to that in 2001?
Keep it short and to the point. 1.17. What is the ratio of the Aid flow (current US$) of Germany in 1997 to that in 2001?
Keep it short and to the point. 2.25. What is the ratio of the Aid flow (current US$) in Japan in 1997 to that in 2001?
Your answer should be very brief. 1.13. What is the ratio of the Aid flow (current US$) in France in 1997 to that in 2002?
Keep it short and to the point. 0.65. What is the ratio of the Aid flow (current US$) in Germany in 1997 to that in 2002?
Provide a succinct answer. 3.21. What is the ratio of the Aid flow (current US$) in Japan in 1997 to that in 2002?
Make the answer very short. 1.79. What is the ratio of the Aid flow (current US$) in France in 1997 to that in 2003?
Provide a short and direct response. 0.67. What is the ratio of the Aid flow (current US$) in Germany in 1997 to that in 2003?
Keep it short and to the point. 4.18. What is the ratio of the Aid flow (current US$) of Japan in 1997 to that in 2003?
Make the answer very short. 2.01. What is the ratio of the Aid flow (current US$) in France in 1998 to that in 1999?
Your response must be concise. 0.64. What is the ratio of the Aid flow (current US$) in Germany in 1998 to that in 1999?
Ensure brevity in your answer.  1.21. What is the ratio of the Aid flow (current US$) of Japan in 1998 to that in 1999?
Give a very brief answer. 1.49. What is the ratio of the Aid flow (current US$) of France in 1998 to that in 2000?
Provide a short and direct response. 0.65. What is the ratio of the Aid flow (current US$) in Germany in 1998 to that in 2000?
Provide a succinct answer. 1.44. What is the ratio of the Aid flow (current US$) of Italy in 1998 to that in 2000?
Offer a very short reply. 0.56. What is the ratio of the Aid flow (current US$) in Japan in 1998 to that in 2000?
Ensure brevity in your answer.  0.74. What is the ratio of the Aid flow (current US$) of France in 1998 to that in 2001?
Your answer should be very brief. 0.7. What is the ratio of the Aid flow (current US$) of Germany in 1998 to that in 2001?
Give a very brief answer. 1.51. What is the ratio of the Aid flow (current US$) of Japan in 1998 to that in 2001?
Offer a terse response. 0.7. What is the ratio of the Aid flow (current US$) in France in 1998 to that in 2002?
Provide a succinct answer. 0.39. What is the ratio of the Aid flow (current US$) of Germany in 1998 to that in 2002?
Offer a terse response. 2.17. What is the ratio of the Aid flow (current US$) of Japan in 1998 to that in 2002?
Keep it short and to the point. 1.12. What is the ratio of the Aid flow (current US$) in France in 1998 to that in 2003?
Provide a succinct answer. 0.4. What is the ratio of the Aid flow (current US$) of Germany in 1998 to that in 2003?
Your answer should be compact. 2.81. What is the ratio of the Aid flow (current US$) of Japan in 1998 to that in 2003?
Offer a terse response. 1.26. What is the ratio of the Aid flow (current US$) in France in 1999 to that in 2000?
Provide a succinct answer. 1. What is the ratio of the Aid flow (current US$) in Germany in 1999 to that in 2000?
Offer a terse response. 1.19. What is the ratio of the Aid flow (current US$) in Japan in 1999 to that in 2000?
Provide a short and direct response. 0.5. What is the ratio of the Aid flow (current US$) in France in 1999 to that in 2001?
Keep it short and to the point. 1.08. What is the ratio of the Aid flow (current US$) of Germany in 1999 to that in 2001?
Offer a terse response. 1.25. What is the ratio of the Aid flow (current US$) of Japan in 1999 to that in 2001?
Provide a succinct answer. 0.47. What is the ratio of the Aid flow (current US$) of France in 1999 to that in 2002?
Give a very brief answer. 0.6. What is the ratio of the Aid flow (current US$) of Germany in 1999 to that in 2002?
Keep it short and to the point. 1.79. What is the ratio of the Aid flow (current US$) of Japan in 1999 to that in 2002?
Your answer should be compact. 0.75. What is the ratio of the Aid flow (current US$) of France in 1999 to that in 2003?
Keep it short and to the point. 0.62. What is the ratio of the Aid flow (current US$) in Germany in 1999 to that in 2003?
Your answer should be compact. 2.33. What is the ratio of the Aid flow (current US$) in Japan in 1999 to that in 2003?
Ensure brevity in your answer.  0.84. What is the ratio of the Aid flow (current US$) of France in 2000 to that in 2001?
Provide a succinct answer. 1.07. What is the ratio of the Aid flow (current US$) of Germany in 2000 to that in 2001?
Provide a short and direct response. 1.05. What is the ratio of the Aid flow (current US$) of Japan in 2000 to that in 2001?
Make the answer very short. 0.94. What is the ratio of the Aid flow (current US$) in France in 2000 to that in 2002?
Provide a succinct answer. 0.6. What is the ratio of the Aid flow (current US$) in Germany in 2000 to that in 2002?
Offer a terse response. 1.51. What is the ratio of the Aid flow (current US$) of Japan in 2000 to that in 2002?
Keep it short and to the point. 1.51. What is the ratio of the Aid flow (current US$) of France in 2000 to that in 2003?
Offer a terse response. 0.62. What is the ratio of the Aid flow (current US$) in Germany in 2000 to that in 2003?
Make the answer very short. 1.96. What is the ratio of the Aid flow (current US$) of Japan in 2000 to that in 2003?
Provide a short and direct response. 1.69. What is the ratio of the Aid flow (current US$) in France in 2001 to that in 2002?
Keep it short and to the point. 0.55. What is the ratio of the Aid flow (current US$) in Germany in 2001 to that in 2002?
Your response must be concise. 1.43. What is the ratio of the Aid flow (current US$) in Japan in 2001 to that in 2002?
Your response must be concise. 1.59. What is the ratio of the Aid flow (current US$) of France in 2001 to that in 2003?
Give a very brief answer. 0.58. What is the ratio of the Aid flow (current US$) in Germany in 2001 to that in 2003?
Your response must be concise. 1.86. What is the ratio of the Aid flow (current US$) in Japan in 2001 to that in 2003?
Provide a short and direct response. 1.79. What is the ratio of the Aid flow (current US$) of France in 2002 to that in 2003?
Ensure brevity in your answer.  1.04. What is the ratio of the Aid flow (current US$) of Germany in 2002 to that in 2003?
Your response must be concise. 1.3. What is the ratio of the Aid flow (current US$) in Japan in 2002 to that in 2003?
Offer a terse response. 1.12. What is the difference between the highest and the second highest Aid flow (current US$) in France?
Your answer should be compact. 2.00e+07. What is the difference between the highest and the second highest Aid flow (current US$) of Germany?
Provide a short and direct response. 2.23e+08. What is the difference between the highest and the second highest Aid flow (current US$) in Italy?
Offer a terse response. 5.84e+07. What is the difference between the highest and the second highest Aid flow (current US$) of Japan?
Your answer should be very brief. 9.93e+07. What is the difference between the highest and the lowest Aid flow (current US$) of France?
Your answer should be compact. 6.74e+07. What is the difference between the highest and the lowest Aid flow (current US$) of Germany?
Give a very brief answer. 5.20e+08. What is the difference between the highest and the lowest Aid flow (current US$) in Italy?
Your answer should be very brief. 6.96e+07. What is the difference between the highest and the lowest Aid flow (current US$) of Japan?
Provide a short and direct response. 9.03e+08. 